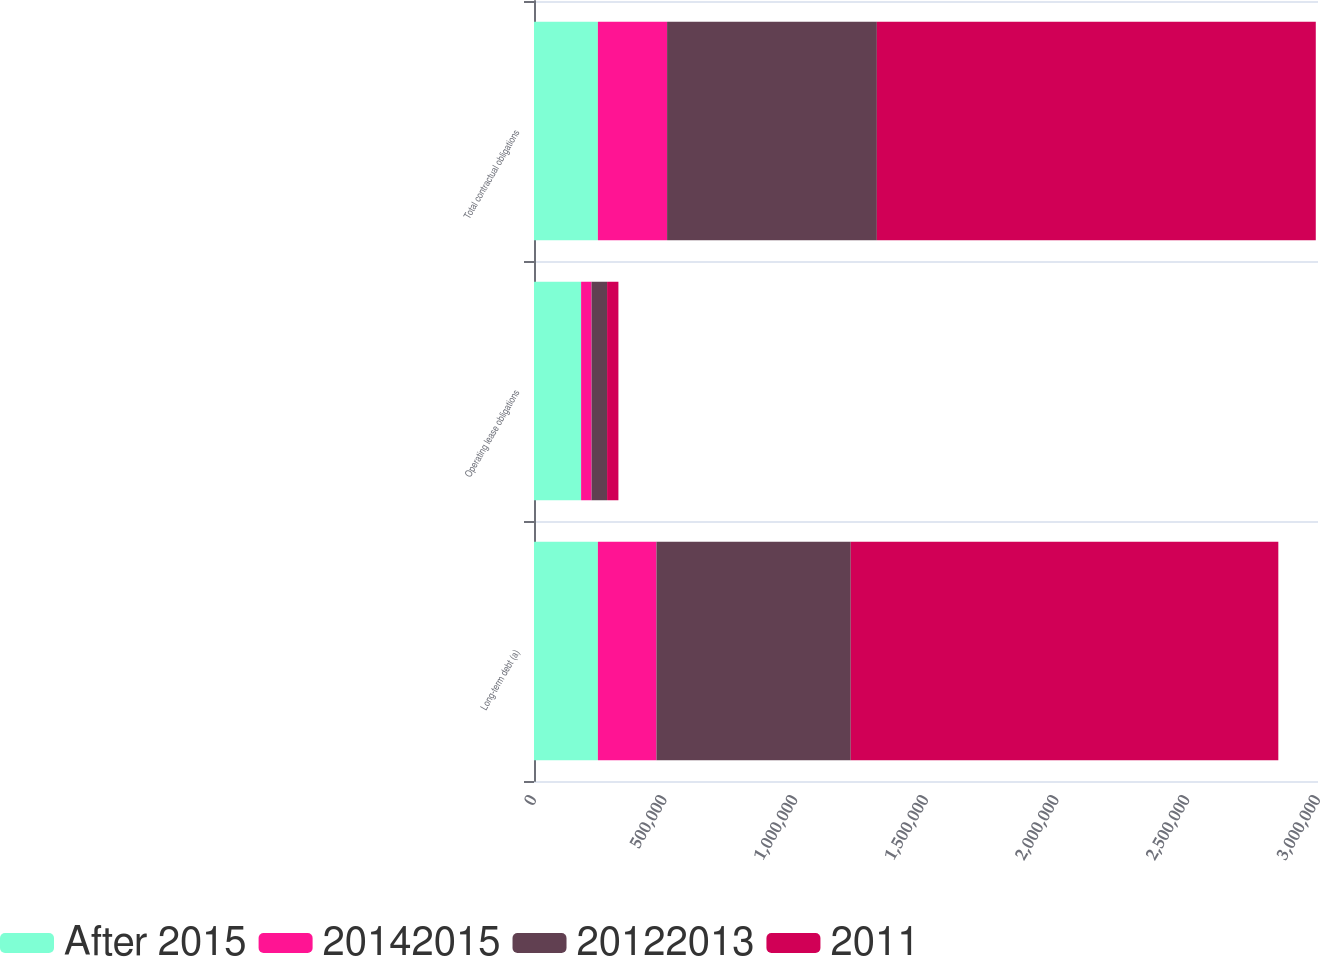<chart> <loc_0><loc_0><loc_500><loc_500><stacked_bar_chart><ecel><fcel>Long-term debt (a)<fcel>Operating lease obligations<fcel>Total contractual obligations<nl><fcel>After 2015<fcel>244469<fcel>180258<fcel>244469<nl><fcel>20142015<fcel>224157<fcel>40028<fcel>264781<nl><fcel>20122013<fcel>743379<fcel>59368<fcel>802747<nl><fcel>2011<fcel>1.63617e+06<fcel>43352<fcel>1.67953e+06<nl></chart> 